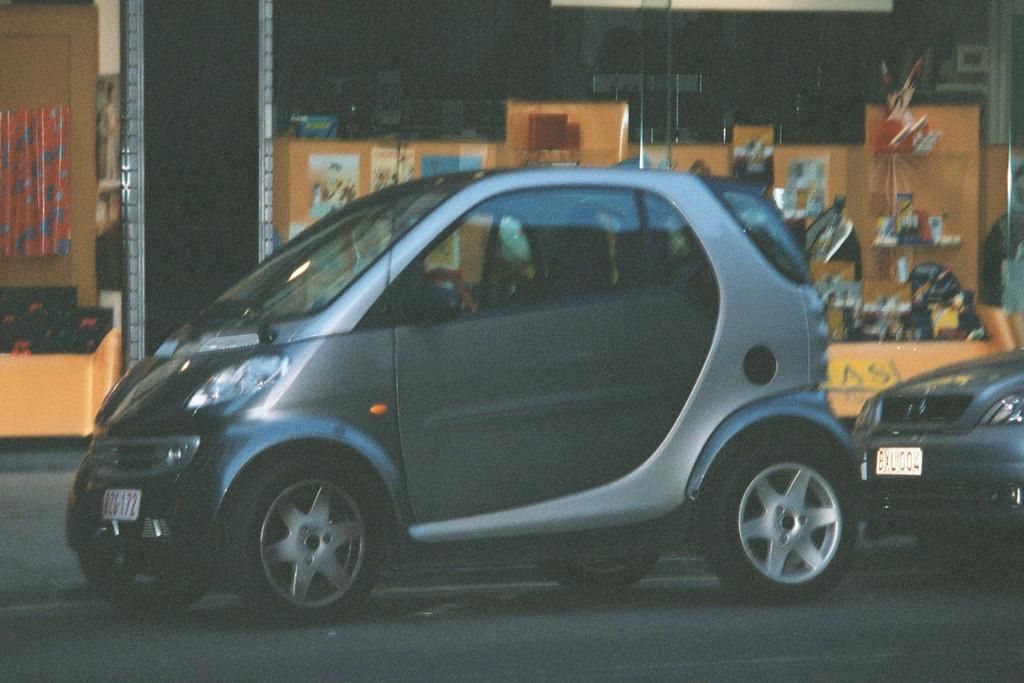What is happening in the image involving vehicles? There is a car moving on the road in the image, and another car is following it. What can be seen in the background of the image? The background of the image includes a building. What type of establishment is located near the building? There are stores in front of the building. What type of baseball equipment can be seen in the image? There is no baseball equipment present in the image. What kind of toys are visible in the image? There are no toys visible in the image. 